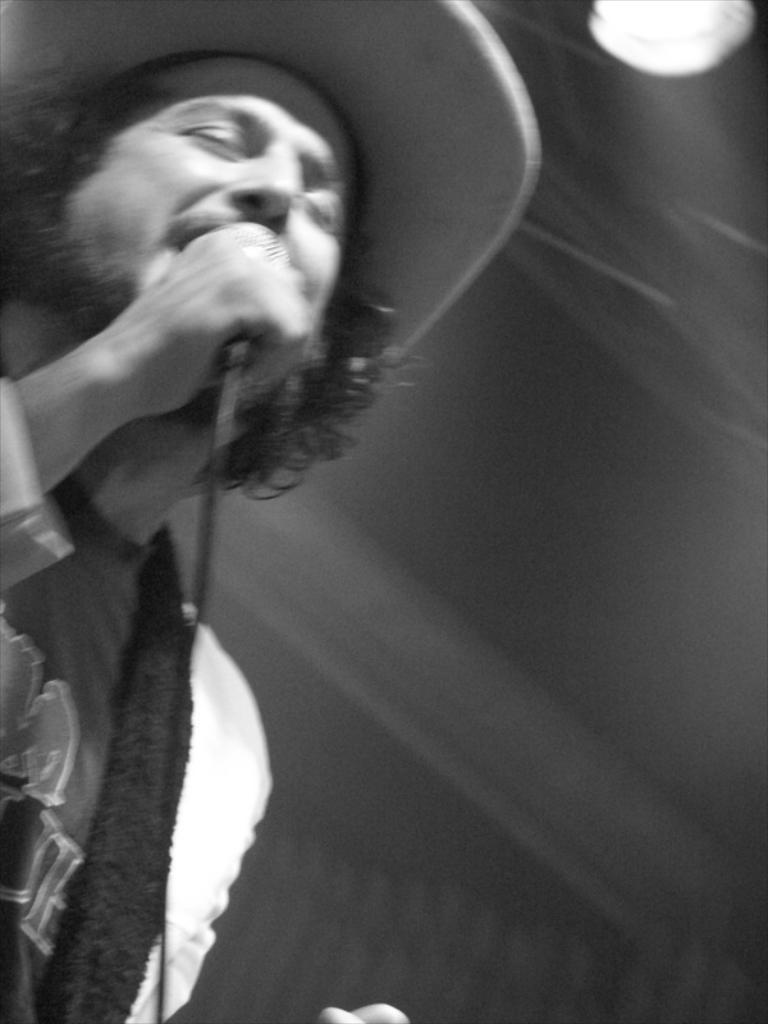What is the man in the image doing? The man is singing in the image. What object is the man holding in the image? The man is holding a microphone in the image. What is the man's facial expression in the image? The man has his eyes closed in the image. What type of headwear is the man wearing in the image? The man is wearing a hat in the image. How many snakes are wrapped around the man's legs in the image? There are no snakes present in the image. What type of pail is the man using to climb the mountain in the image? There is no mountain or pail present in the image. 